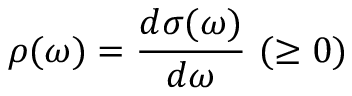Convert formula to latex. <formula><loc_0><loc_0><loc_500><loc_500>\rho ( \omega ) = \frac { d \sigma ( \omega ) } { d \omega } ( \geq 0 )</formula> 